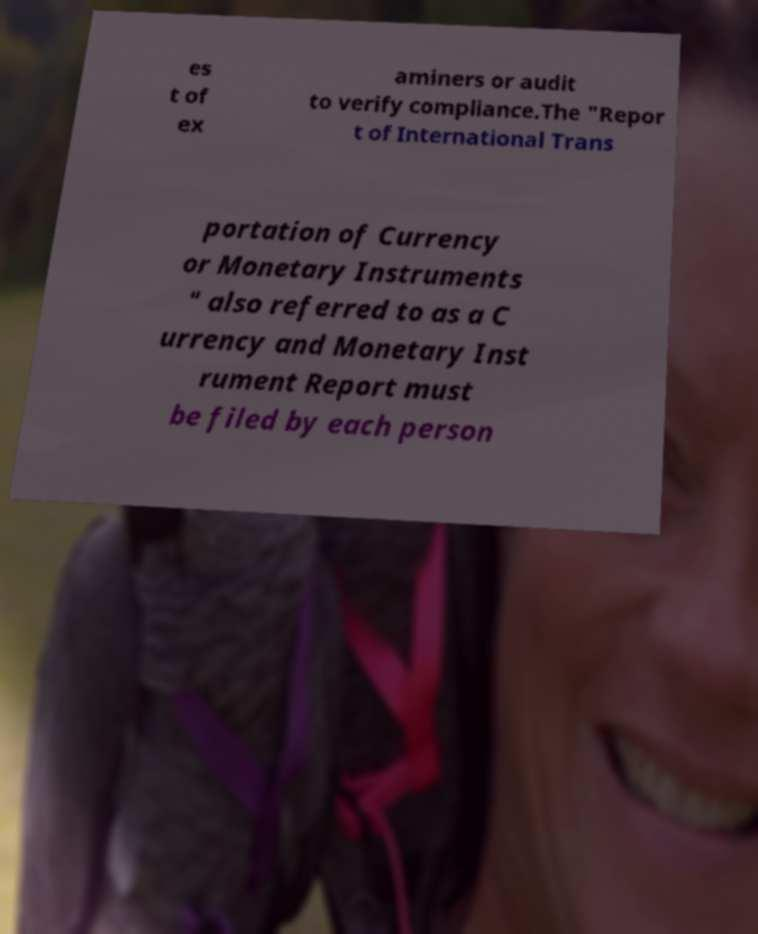Please identify and transcribe the text found in this image. es t of ex aminers or audit to verify compliance.The "Repor t of International Trans portation of Currency or Monetary Instruments " also referred to as a C urrency and Monetary Inst rument Report must be filed by each person 